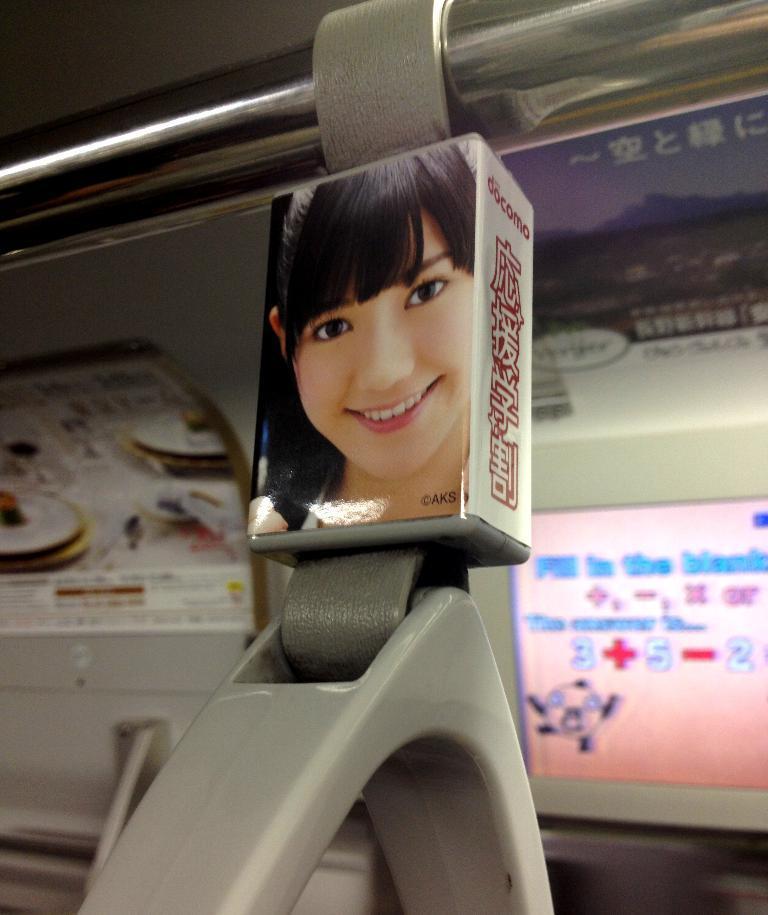In one or two sentences, can you explain what this image depicts? In this picture we can see a few posters. We can see some text, numbers, symbols and a few figures on the posters. There is a rod and other objects. 